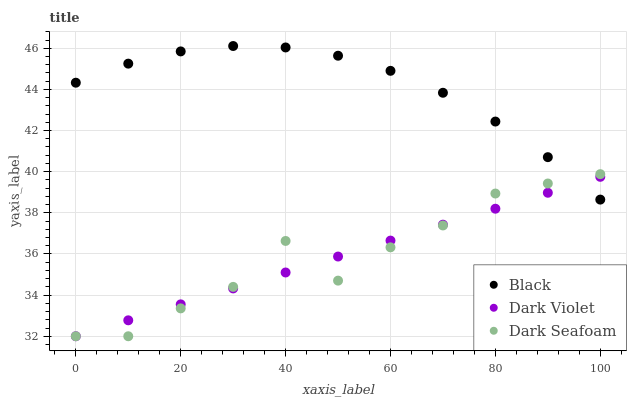Does Dark Violet have the minimum area under the curve?
Answer yes or no. Yes. Does Black have the maximum area under the curve?
Answer yes or no. Yes. Does Black have the minimum area under the curve?
Answer yes or no. No. Does Dark Violet have the maximum area under the curve?
Answer yes or no. No. Is Dark Violet the smoothest?
Answer yes or no. Yes. Is Dark Seafoam the roughest?
Answer yes or no. Yes. Is Black the smoothest?
Answer yes or no. No. Is Black the roughest?
Answer yes or no. No. Does Dark Seafoam have the lowest value?
Answer yes or no. Yes. Does Black have the lowest value?
Answer yes or no. No. Does Black have the highest value?
Answer yes or no. Yes. Does Dark Violet have the highest value?
Answer yes or no. No. Does Dark Seafoam intersect Dark Violet?
Answer yes or no. Yes. Is Dark Seafoam less than Dark Violet?
Answer yes or no. No. Is Dark Seafoam greater than Dark Violet?
Answer yes or no. No. 